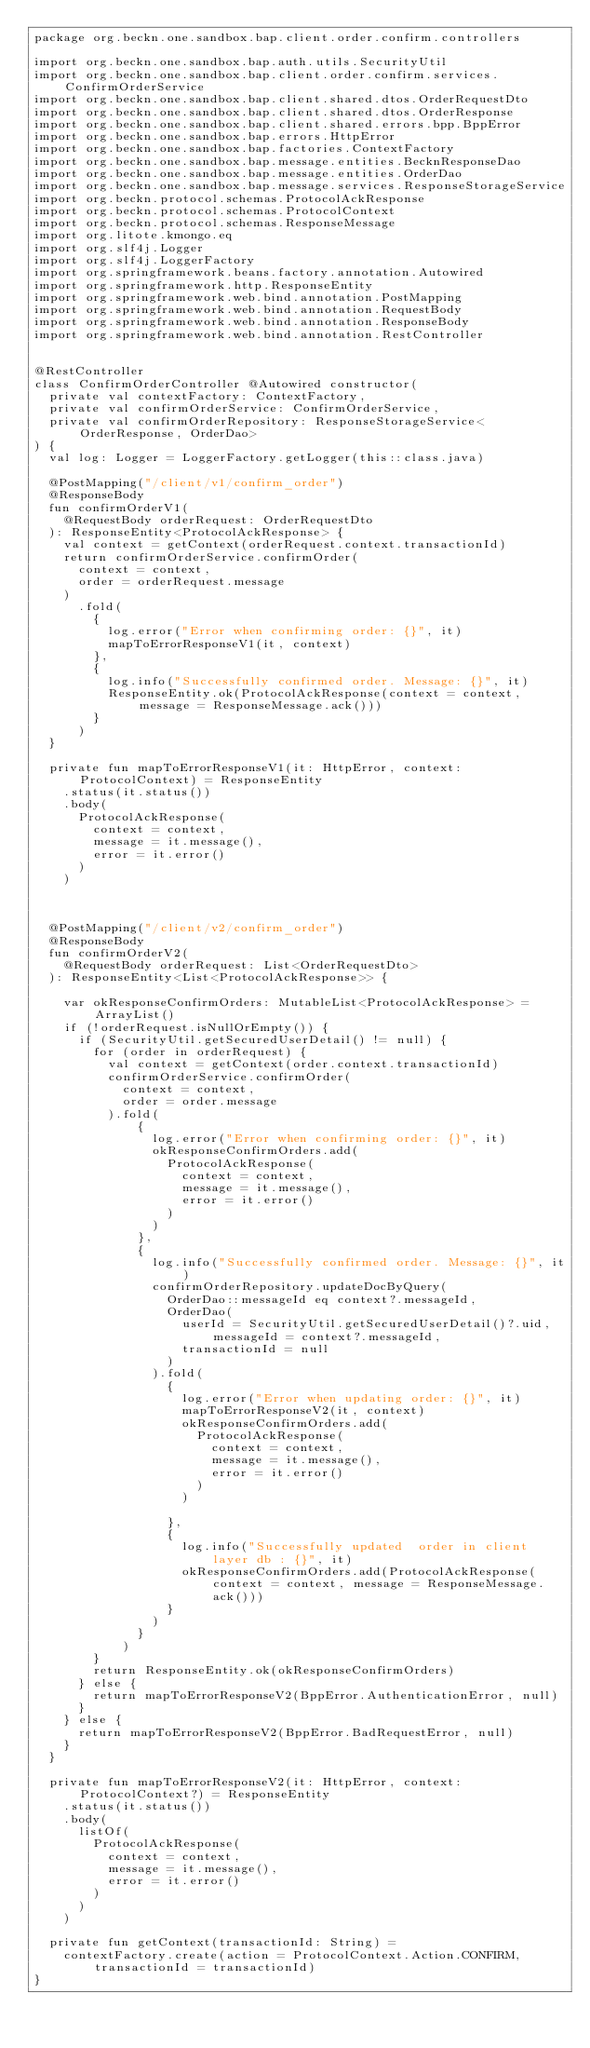<code> <loc_0><loc_0><loc_500><loc_500><_Kotlin_>package org.beckn.one.sandbox.bap.client.order.confirm.controllers

import org.beckn.one.sandbox.bap.auth.utils.SecurityUtil
import org.beckn.one.sandbox.bap.client.order.confirm.services.ConfirmOrderService
import org.beckn.one.sandbox.bap.client.shared.dtos.OrderRequestDto
import org.beckn.one.sandbox.bap.client.shared.dtos.OrderResponse
import org.beckn.one.sandbox.bap.client.shared.errors.bpp.BppError
import org.beckn.one.sandbox.bap.errors.HttpError
import org.beckn.one.sandbox.bap.factories.ContextFactory
import org.beckn.one.sandbox.bap.message.entities.BecknResponseDao
import org.beckn.one.sandbox.bap.message.entities.OrderDao
import org.beckn.one.sandbox.bap.message.services.ResponseStorageService
import org.beckn.protocol.schemas.ProtocolAckResponse
import org.beckn.protocol.schemas.ProtocolContext
import org.beckn.protocol.schemas.ResponseMessage
import org.litote.kmongo.eq
import org.slf4j.Logger
import org.slf4j.LoggerFactory
import org.springframework.beans.factory.annotation.Autowired
import org.springframework.http.ResponseEntity
import org.springframework.web.bind.annotation.PostMapping
import org.springframework.web.bind.annotation.RequestBody
import org.springframework.web.bind.annotation.ResponseBody
import org.springframework.web.bind.annotation.RestController


@RestController
class ConfirmOrderController @Autowired constructor(
  private val contextFactory: ContextFactory,
  private val confirmOrderService: ConfirmOrderService,
  private val confirmOrderRepository: ResponseStorageService<OrderResponse, OrderDao>
) {
  val log: Logger = LoggerFactory.getLogger(this::class.java)

  @PostMapping("/client/v1/confirm_order")
  @ResponseBody
  fun confirmOrderV1(
    @RequestBody orderRequest: OrderRequestDto
  ): ResponseEntity<ProtocolAckResponse> {
    val context = getContext(orderRequest.context.transactionId)
    return confirmOrderService.confirmOrder(
      context = context,
      order = orderRequest.message
    )
      .fold(
        {
          log.error("Error when confirming order: {}", it)
          mapToErrorResponseV1(it, context)
        },
        {
          log.info("Successfully confirmed order. Message: {}", it)
          ResponseEntity.ok(ProtocolAckResponse(context = context, message = ResponseMessage.ack()))
        }
      )
  }

  private fun mapToErrorResponseV1(it: HttpError, context: ProtocolContext) = ResponseEntity
    .status(it.status())
    .body(
      ProtocolAckResponse(
        context = context,
        message = it.message(),
        error = it.error()
      )
    )



  @PostMapping("/client/v2/confirm_order")
  @ResponseBody
  fun confirmOrderV2(
    @RequestBody orderRequest: List<OrderRequestDto>
  ): ResponseEntity<List<ProtocolAckResponse>> {

    var okResponseConfirmOrders: MutableList<ProtocolAckResponse> = ArrayList()
    if (!orderRequest.isNullOrEmpty()) {
      if (SecurityUtil.getSecuredUserDetail() != null) {
        for (order in orderRequest) {
          val context = getContext(order.context.transactionId)
          confirmOrderService.confirmOrder(
            context = context,
            order = order.message
          ).fold(
              {
                log.error("Error when confirming order: {}", it)
                okResponseConfirmOrders.add(
                  ProtocolAckResponse(
                    context = context,
                    message = it.message(),
                    error = it.error()
                  )
                )
              },
              {
                log.info("Successfully confirmed order. Message: {}", it)
                confirmOrderRepository.updateDocByQuery(
                  OrderDao::messageId eq context?.messageId,
                  OrderDao(
                    userId = SecurityUtil.getSecuredUserDetail()?.uid, messageId = context?.messageId,
                    transactionId = null
                  )
                ).fold(
                  {
                    log.error("Error when updating order: {}", it)
                    mapToErrorResponseV2(it, context)
                    okResponseConfirmOrders.add(
                      ProtocolAckResponse(
                        context = context,
                        message = it.message(),
                        error = it.error()
                      )
                    )

                  },
                  {
                    log.info("Successfully updated  order in client layer db : {}", it)
                    okResponseConfirmOrders.add(ProtocolAckResponse(context = context, message = ResponseMessage.ack()))
                  }
                )
              }
            )
        }
        return ResponseEntity.ok(okResponseConfirmOrders)
      } else {
        return mapToErrorResponseV2(BppError.AuthenticationError, null)
      }
    } else {
      return mapToErrorResponseV2(BppError.BadRequestError, null)
    }
  }

  private fun mapToErrorResponseV2(it: HttpError, context: ProtocolContext?) = ResponseEntity
    .status(it.status())
    .body(
      listOf(
        ProtocolAckResponse(
          context = context,
          message = it.message(),
          error = it.error()
        )
      )
    )

  private fun getContext(transactionId: String) =
    contextFactory.create(action = ProtocolContext.Action.CONFIRM, transactionId = transactionId)
}</code> 